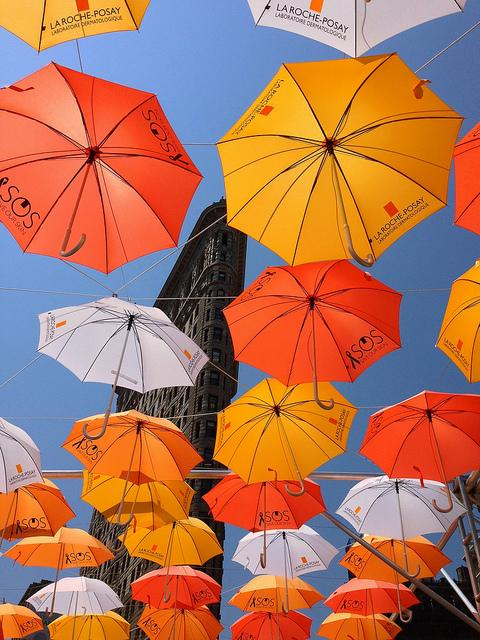What larger makeup group owns this company? Please explain your reasoning. l'oreal. Logos are on a group of umbrellas. 